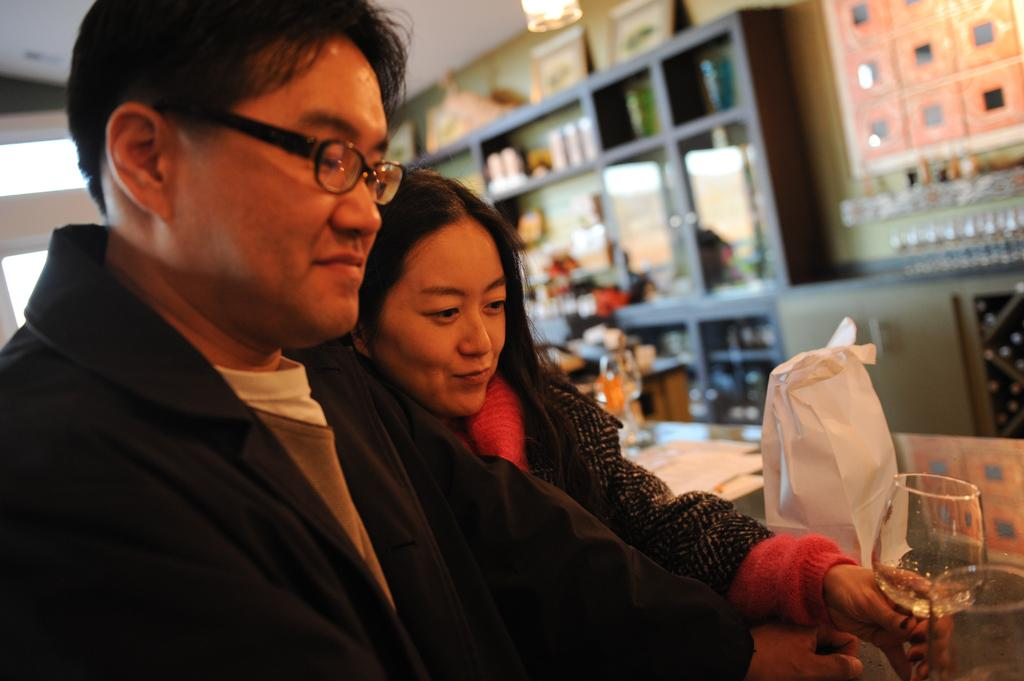How many people are in the image? There are people in the image, but the exact number is not specified. What is the woman holding in the image? The woman is holding a glass in the image. What can be seen covering something in the image? There is a cover visible in the image. What can be said about the background of the image? The background of the image is blurry. Where is the light coming from in the image? Light is visible at the top of the image. What type of cracker is being used to attack the people in the image? There is no cracker or attack present in the image; it features people with a woman holding a glass and a cover visible. 